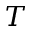Convert formula to latex. <formula><loc_0><loc_0><loc_500><loc_500>T</formula> 